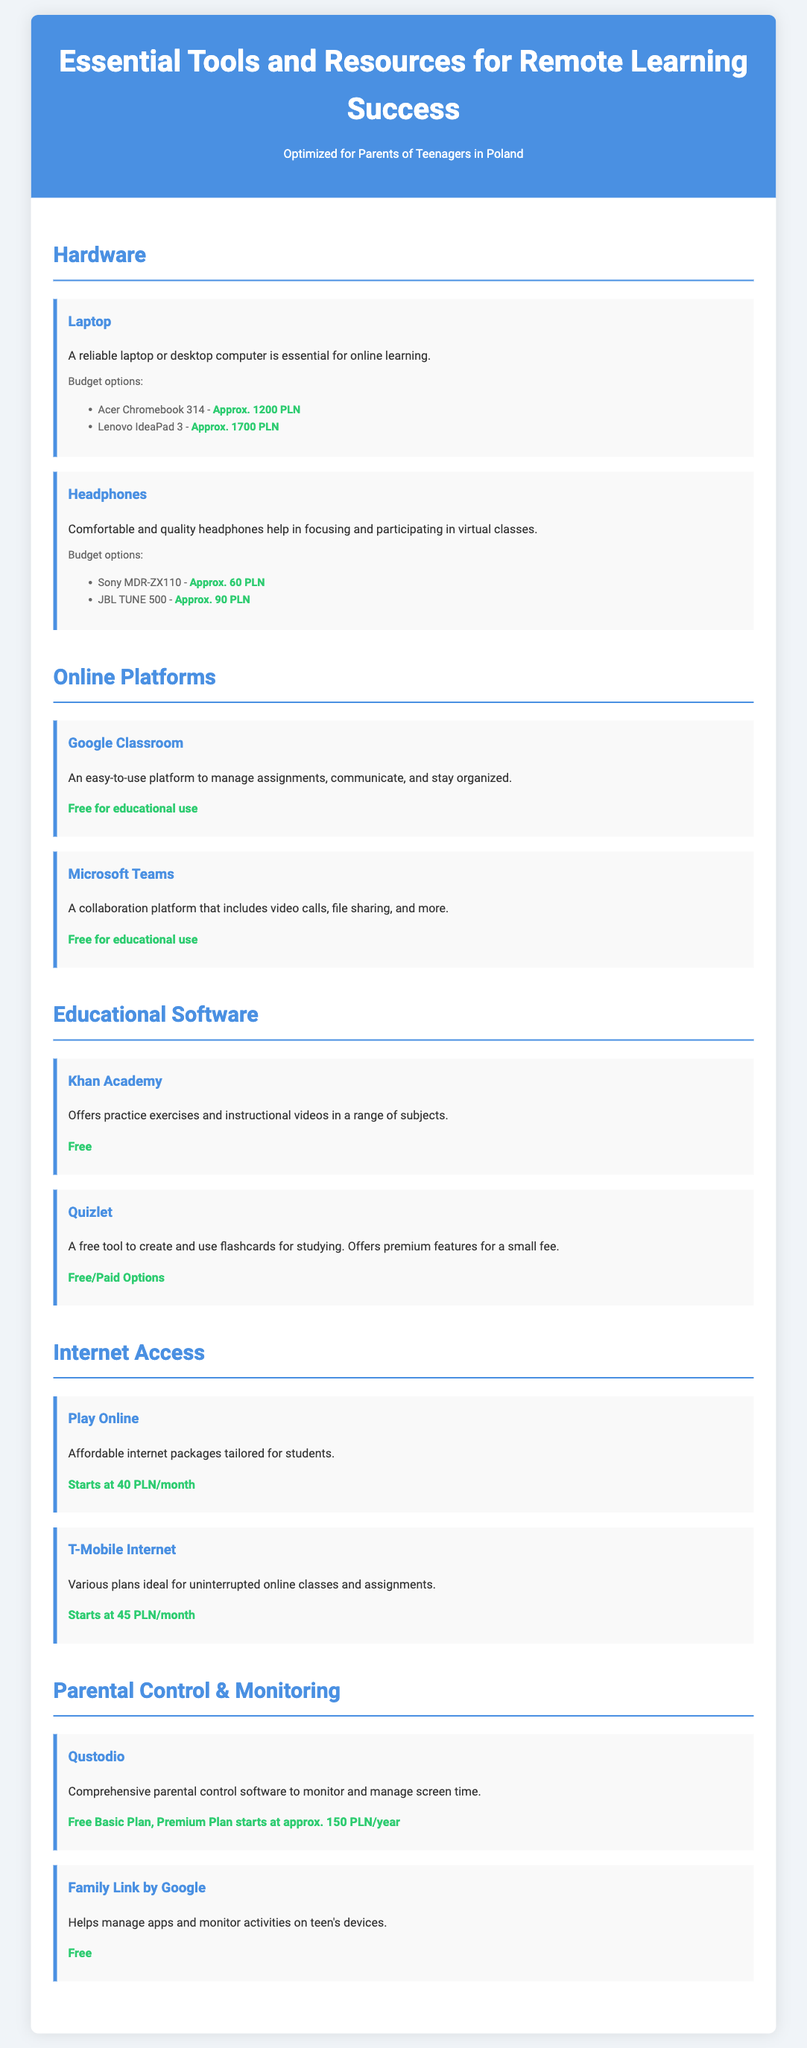What is one budget-friendly laptop option? The document lists specific budget options for laptops, including the Acer Chromebook 314.
Answer: Acer Chromebook 314 What is the price of Sony MDR-ZX110 headphones? The document provides a price for the Sony MDR-ZX110 headphones as a budget-friendly option.
Answer: Approx. 60 PLN How much does Play Online internet access start at? The document specifies the starting price for Play Online internet access packages.
Answer: Starts at 40 PLN/month What free online platform helps manage assignments? Google Classroom is mentioned in the document as a platform for managing assignments.
Answer: Google Classroom What is the premium plan price for Qustodio? The document indicates the cost of the premium plan for Qustodio parental control software.
Answer: Approx. 150 PLN/year Which educational software offers practice exercises? The document identifies Khan Academy as an educational software that provides practice exercises.
Answer: Khan Academy How many budget headphone options are listed? The document lists two budget options for headphones.
Answer: Two Which platform is free for educational use and includes video calls? The document mentions Microsoft Teams as a platform that includes video calls and is free for educational use.
Answer: Microsoft Teams 